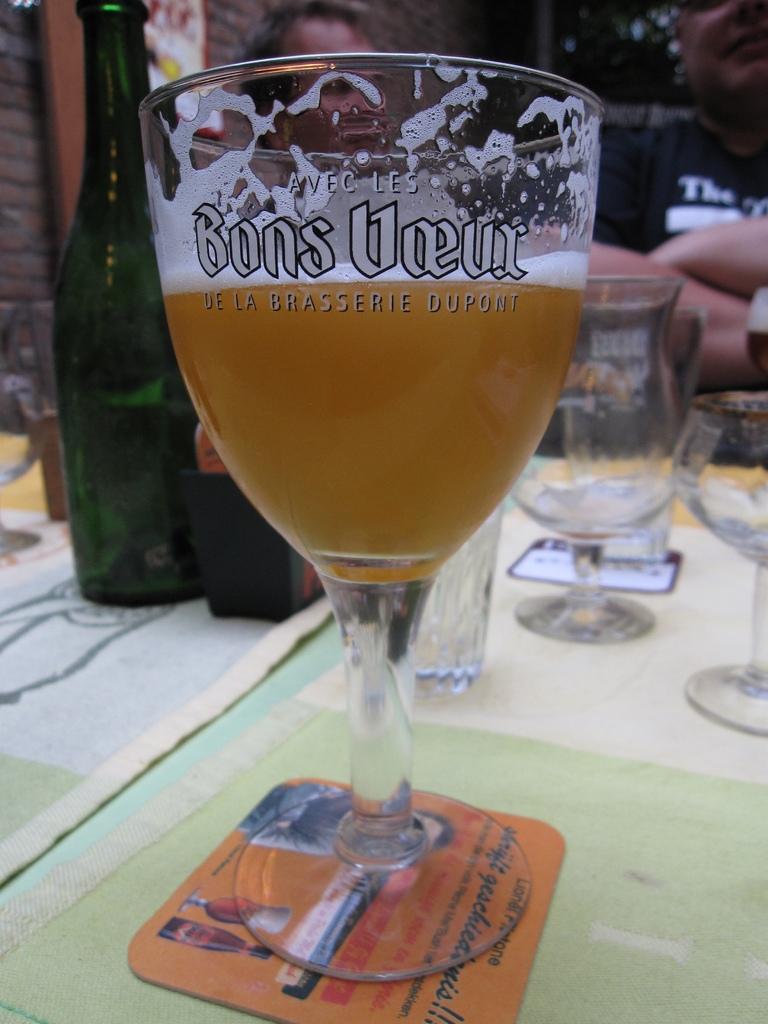What company is advetrtised on the glass?
Provide a short and direct response. Bons voeux. What is the tag line on the glass?
Offer a very short reply. De la brasserie dupont. 